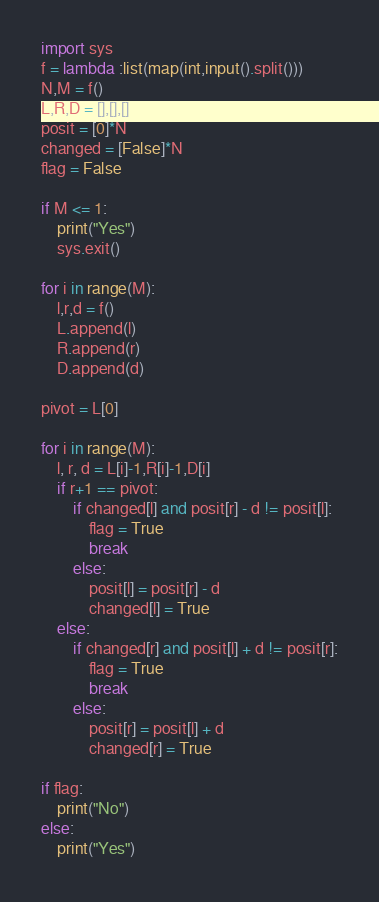Convert code to text. <code><loc_0><loc_0><loc_500><loc_500><_Python_>import sys
f = lambda :list(map(int,input().split()))
N,M = f()
L,R,D = [],[],[]
posit = [0]*N
changed = [False]*N
flag = False

if M <= 1:
    print("Yes")
    sys.exit()

for i in range(M):
    l,r,d = f()
    L.append(l)
    R.append(r)
    D.append(d)

pivot = L[0]

for i in range(M):
    l, r, d = L[i]-1,R[i]-1,D[i]
    if r+1 == pivot:
        if changed[l] and posit[r] - d != posit[l]:
            flag = True
            break
        else:
            posit[l] = posit[r] - d
            changed[l] = True
    else:
        if changed[r] and posit[l] + d != posit[r]:
            flag = True
            break
        else:
            posit[r] = posit[l] + d
            changed[r] = True

if flag:
    print("No")
else:
    print("Yes")</code> 